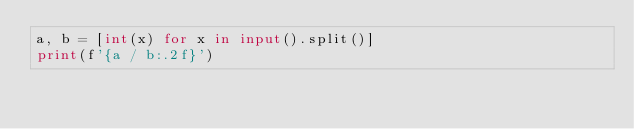<code> <loc_0><loc_0><loc_500><loc_500><_Python_>a, b = [int(x) for x in input().split()]
print(f'{a / b:.2f}')</code> 